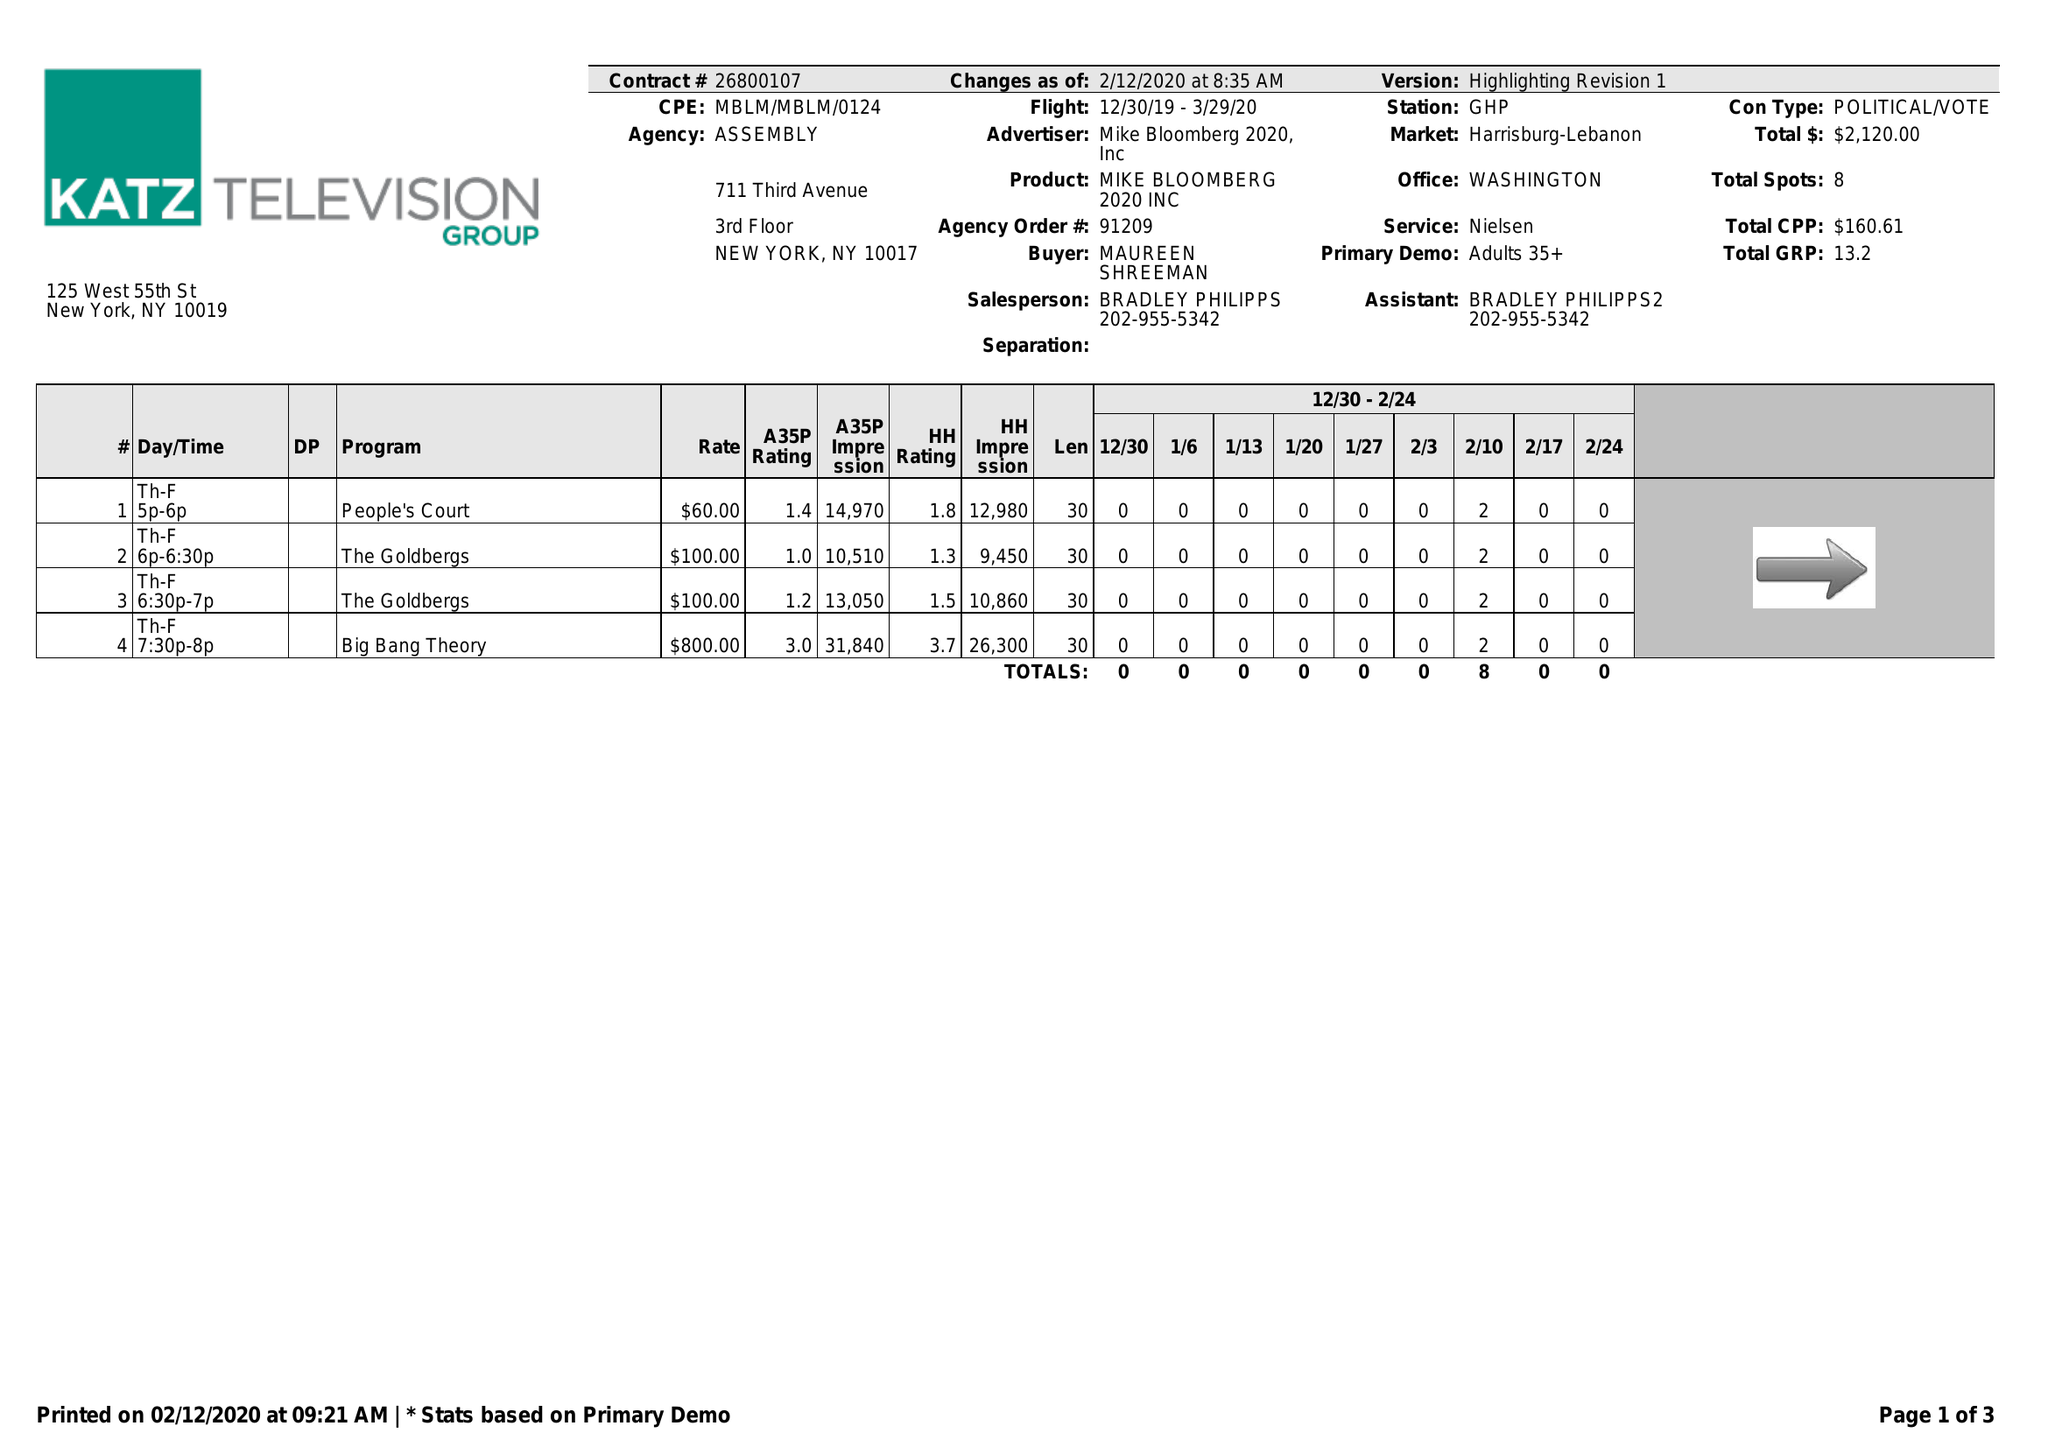What is the value for the contract_num?
Answer the question using a single word or phrase. 26800107 